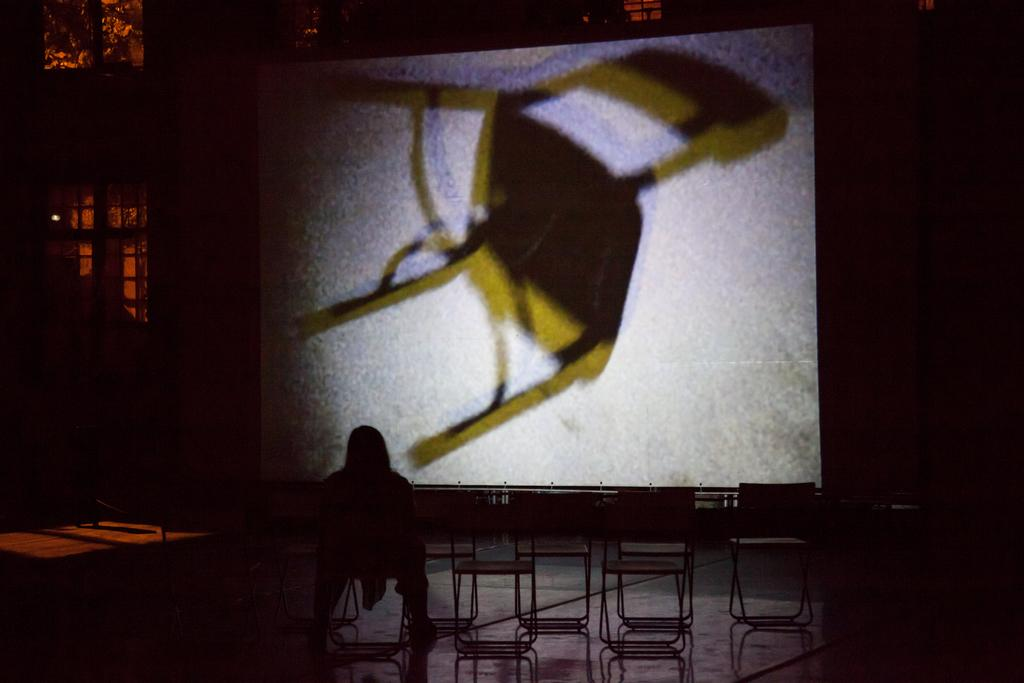What is the person in the image doing? The person is sitting on a chair in the image. How many chairs are visible in the image? There are multiple chairs in the image. What is the purpose of the screen in the image? The screen displays an image of a chair. What type of music is being played in the background of the image? There is no information about music being played in the image, as the focus is on the person, chairs, and screen. 